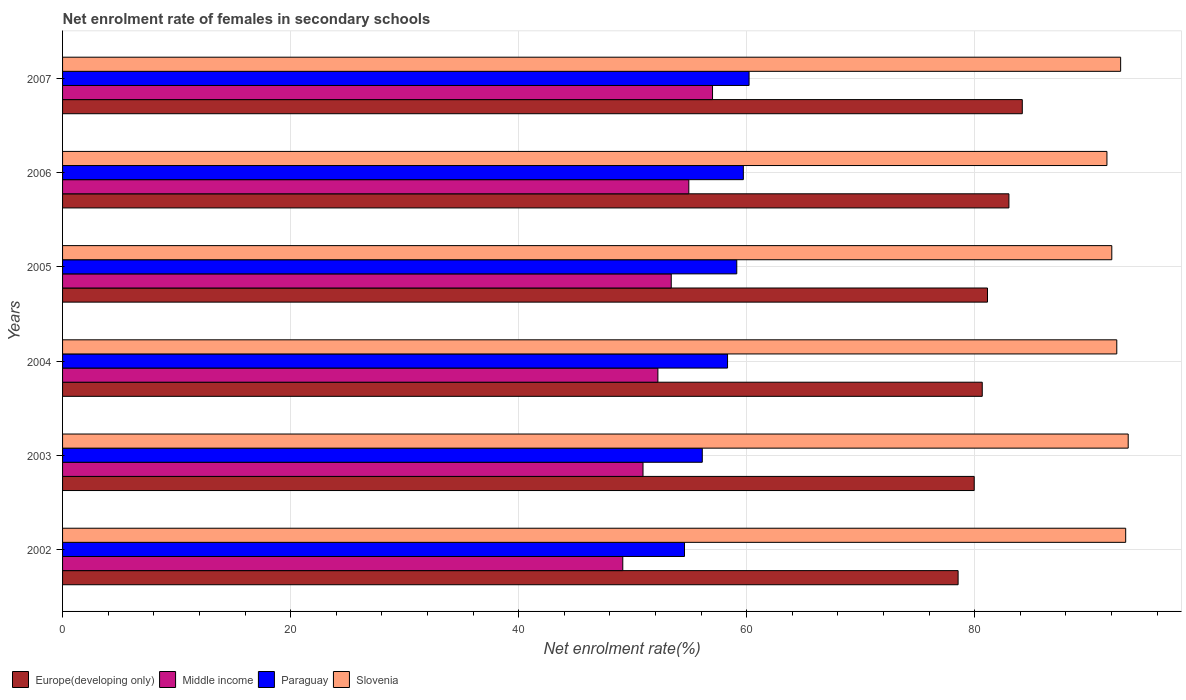How many groups of bars are there?
Provide a short and direct response. 6. Are the number of bars per tick equal to the number of legend labels?
Your response must be concise. Yes. What is the label of the 1st group of bars from the top?
Your answer should be compact. 2007. In how many cases, is the number of bars for a given year not equal to the number of legend labels?
Your answer should be very brief. 0. What is the net enrolment rate of females in secondary schools in Slovenia in 2007?
Your response must be concise. 92.8. Across all years, what is the maximum net enrolment rate of females in secondary schools in Europe(developing only)?
Your answer should be very brief. 84.17. Across all years, what is the minimum net enrolment rate of females in secondary schools in Paraguay?
Provide a succinct answer. 54.55. In which year was the net enrolment rate of females in secondary schools in Paraguay minimum?
Offer a terse response. 2002. What is the total net enrolment rate of females in secondary schools in Slovenia in the graph?
Provide a short and direct response. 555.58. What is the difference between the net enrolment rate of females in secondary schools in Europe(developing only) in 2004 and that in 2007?
Keep it short and to the point. -3.51. What is the difference between the net enrolment rate of females in secondary schools in Paraguay in 2006 and the net enrolment rate of females in secondary schools in Middle income in 2003?
Offer a terse response. 8.8. What is the average net enrolment rate of females in secondary schools in Paraguay per year?
Keep it short and to the point. 58. In the year 2004, what is the difference between the net enrolment rate of females in secondary schools in Slovenia and net enrolment rate of females in secondary schools in Paraguay?
Your response must be concise. 34.14. In how many years, is the net enrolment rate of females in secondary schools in Middle income greater than 36 %?
Provide a succinct answer. 6. What is the ratio of the net enrolment rate of females in secondary schools in Middle income in 2005 to that in 2006?
Ensure brevity in your answer.  0.97. What is the difference between the highest and the second highest net enrolment rate of females in secondary schools in Middle income?
Make the answer very short. 2.08. What is the difference between the highest and the lowest net enrolment rate of females in secondary schools in Middle income?
Your answer should be compact. 7.87. Is the sum of the net enrolment rate of females in secondary schools in Europe(developing only) in 2003 and 2004 greater than the maximum net enrolment rate of females in secondary schools in Slovenia across all years?
Give a very brief answer. Yes. What does the 1st bar from the top in 2004 represents?
Keep it short and to the point. Slovenia. What does the 2nd bar from the bottom in 2007 represents?
Give a very brief answer. Middle income. Is it the case that in every year, the sum of the net enrolment rate of females in secondary schools in Europe(developing only) and net enrolment rate of females in secondary schools in Slovenia is greater than the net enrolment rate of females in secondary schools in Paraguay?
Provide a short and direct response. Yes. How many bars are there?
Provide a short and direct response. 24. Are all the bars in the graph horizontal?
Keep it short and to the point. Yes. What is the difference between two consecutive major ticks on the X-axis?
Provide a succinct answer. 20. Are the values on the major ticks of X-axis written in scientific E-notation?
Your answer should be compact. No. Does the graph contain any zero values?
Provide a short and direct response. No. Does the graph contain grids?
Your answer should be very brief. Yes. How many legend labels are there?
Provide a succinct answer. 4. What is the title of the graph?
Provide a short and direct response. Net enrolment rate of females in secondary schools. What is the label or title of the X-axis?
Offer a very short reply. Net enrolment rate(%). What is the Net enrolment rate(%) of Europe(developing only) in 2002?
Offer a terse response. 78.54. What is the Net enrolment rate(%) in Middle income in 2002?
Give a very brief answer. 49.13. What is the Net enrolment rate(%) in Paraguay in 2002?
Provide a succinct answer. 54.55. What is the Net enrolment rate(%) of Slovenia in 2002?
Your answer should be very brief. 93.24. What is the Net enrolment rate(%) in Europe(developing only) in 2003?
Provide a short and direct response. 79.96. What is the Net enrolment rate(%) of Middle income in 2003?
Make the answer very short. 50.91. What is the Net enrolment rate(%) in Paraguay in 2003?
Your response must be concise. 56.11. What is the Net enrolment rate(%) of Slovenia in 2003?
Keep it short and to the point. 93.46. What is the Net enrolment rate(%) in Europe(developing only) in 2004?
Offer a very short reply. 80.66. What is the Net enrolment rate(%) of Middle income in 2004?
Ensure brevity in your answer.  52.21. What is the Net enrolment rate(%) in Paraguay in 2004?
Provide a succinct answer. 58.32. What is the Net enrolment rate(%) of Slovenia in 2004?
Give a very brief answer. 92.46. What is the Net enrolment rate(%) of Europe(developing only) in 2005?
Your answer should be compact. 81.12. What is the Net enrolment rate(%) in Middle income in 2005?
Offer a terse response. 53.38. What is the Net enrolment rate(%) in Paraguay in 2005?
Make the answer very short. 59.13. What is the Net enrolment rate(%) of Slovenia in 2005?
Make the answer very short. 92.02. What is the Net enrolment rate(%) of Europe(developing only) in 2006?
Make the answer very short. 83. What is the Net enrolment rate(%) of Middle income in 2006?
Offer a terse response. 54.93. What is the Net enrolment rate(%) of Paraguay in 2006?
Provide a succinct answer. 59.71. What is the Net enrolment rate(%) in Slovenia in 2006?
Keep it short and to the point. 91.6. What is the Net enrolment rate(%) in Europe(developing only) in 2007?
Your response must be concise. 84.17. What is the Net enrolment rate(%) of Middle income in 2007?
Your answer should be very brief. 57.01. What is the Net enrolment rate(%) in Paraguay in 2007?
Provide a succinct answer. 60.21. What is the Net enrolment rate(%) of Slovenia in 2007?
Offer a terse response. 92.8. Across all years, what is the maximum Net enrolment rate(%) in Europe(developing only)?
Provide a short and direct response. 84.17. Across all years, what is the maximum Net enrolment rate(%) in Middle income?
Ensure brevity in your answer.  57.01. Across all years, what is the maximum Net enrolment rate(%) in Paraguay?
Give a very brief answer. 60.21. Across all years, what is the maximum Net enrolment rate(%) of Slovenia?
Provide a succinct answer. 93.46. Across all years, what is the minimum Net enrolment rate(%) of Europe(developing only)?
Your answer should be compact. 78.54. Across all years, what is the minimum Net enrolment rate(%) in Middle income?
Your answer should be compact. 49.13. Across all years, what is the minimum Net enrolment rate(%) in Paraguay?
Ensure brevity in your answer.  54.55. Across all years, what is the minimum Net enrolment rate(%) of Slovenia?
Your answer should be compact. 91.6. What is the total Net enrolment rate(%) in Europe(developing only) in the graph?
Offer a very short reply. 487.45. What is the total Net enrolment rate(%) of Middle income in the graph?
Make the answer very short. 317.57. What is the total Net enrolment rate(%) in Paraguay in the graph?
Make the answer very short. 348.02. What is the total Net enrolment rate(%) of Slovenia in the graph?
Keep it short and to the point. 555.58. What is the difference between the Net enrolment rate(%) in Europe(developing only) in 2002 and that in 2003?
Your answer should be compact. -1.41. What is the difference between the Net enrolment rate(%) in Middle income in 2002 and that in 2003?
Ensure brevity in your answer.  -1.77. What is the difference between the Net enrolment rate(%) in Paraguay in 2002 and that in 2003?
Make the answer very short. -1.56. What is the difference between the Net enrolment rate(%) in Slovenia in 2002 and that in 2003?
Your response must be concise. -0.22. What is the difference between the Net enrolment rate(%) of Europe(developing only) in 2002 and that in 2004?
Offer a very short reply. -2.12. What is the difference between the Net enrolment rate(%) in Middle income in 2002 and that in 2004?
Provide a succinct answer. -3.08. What is the difference between the Net enrolment rate(%) of Paraguay in 2002 and that in 2004?
Provide a short and direct response. -3.78. What is the difference between the Net enrolment rate(%) of Slovenia in 2002 and that in 2004?
Give a very brief answer. 0.78. What is the difference between the Net enrolment rate(%) of Europe(developing only) in 2002 and that in 2005?
Offer a terse response. -2.58. What is the difference between the Net enrolment rate(%) of Middle income in 2002 and that in 2005?
Your answer should be very brief. -4.25. What is the difference between the Net enrolment rate(%) in Paraguay in 2002 and that in 2005?
Keep it short and to the point. -4.58. What is the difference between the Net enrolment rate(%) in Slovenia in 2002 and that in 2005?
Your answer should be compact. 1.22. What is the difference between the Net enrolment rate(%) in Europe(developing only) in 2002 and that in 2006?
Make the answer very short. -4.46. What is the difference between the Net enrolment rate(%) of Middle income in 2002 and that in 2006?
Make the answer very short. -5.79. What is the difference between the Net enrolment rate(%) of Paraguay in 2002 and that in 2006?
Give a very brief answer. -5.16. What is the difference between the Net enrolment rate(%) in Slovenia in 2002 and that in 2006?
Ensure brevity in your answer.  1.64. What is the difference between the Net enrolment rate(%) of Europe(developing only) in 2002 and that in 2007?
Ensure brevity in your answer.  -5.63. What is the difference between the Net enrolment rate(%) in Middle income in 2002 and that in 2007?
Offer a very short reply. -7.87. What is the difference between the Net enrolment rate(%) in Paraguay in 2002 and that in 2007?
Offer a very short reply. -5.66. What is the difference between the Net enrolment rate(%) in Slovenia in 2002 and that in 2007?
Keep it short and to the point. 0.44. What is the difference between the Net enrolment rate(%) in Europe(developing only) in 2003 and that in 2004?
Keep it short and to the point. -0.7. What is the difference between the Net enrolment rate(%) of Middle income in 2003 and that in 2004?
Your answer should be very brief. -1.3. What is the difference between the Net enrolment rate(%) in Paraguay in 2003 and that in 2004?
Make the answer very short. -2.22. What is the difference between the Net enrolment rate(%) in Europe(developing only) in 2003 and that in 2005?
Give a very brief answer. -1.16. What is the difference between the Net enrolment rate(%) of Middle income in 2003 and that in 2005?
Give a very brief answer. -2.48. What is the difference between the Net enrolment rate(%) of Paraguay in 2003 and that in 2005?
Your response must be concise. -3.02. What is the difference between the Net enrolment rate(%) of Slovenia in 2003 and that in 2005?
Provide a short and direct response. 1.44. What is the difference between the Net enrolment rate(%) in Europe(developing only) in 2003 and that in 2006?
Offer a terse response. -3.04. What is the difference between the Net enrolment rate(%) in Middle income in 2003 and that in 2006?
Your answer should be very brief. -4.02. What is the difference between the Net enrolment rate(%) of Paraguay in 2003 and that in 2006?
Give a very brief answer. -3.6. What is the difference between the Net enrolment rate(%) in Slovenia in 2003 and that in 2006?
Provide a short and direct response. 1.87. What is the difference between the Net enrolment rate(%) of Europe(developing only) in 2003 and that in 2007?
Your answer should be very brief. -4.22. What is the difference between the Net enrolment rate(%) of Middle income in 2003 and that in 2007?
Your response must be concise. -6.1. What is the difference between the Net enrolment rate(%) of Paraguay in 2003 and that in 2007?
Provide a short and direct response. -4.1. What is the difference between the Net enrolment rate(%) of Slovenia in 2003 and that in 2007?
Your answer should be compact. 0.66. What is the difference between the Net enrolment rate(%) in Europe(developing only) in 2004 and that in 2005?
Give a very brief answer. -0.46. What is the difference between the Net enrolment rate(%) in Middle income in 2004 and that in 2005?
Keep it short and to the point. -1.17. What is the difference between the Net enrolment rate(%) in Paraguay in 2004 and that in 2005?
Your answer should be very brief. -0.81. What is the difference between the Net enrolment rate(%) in Slovenia in 2004 and that in 2005?
Give a very brief answer. 0.44. What is the difference between the Net enrolment rate(%) of Europe(developing only) in 2004 and that in 2006?
Make the answer very short. -2.34. What is the difference between the Net enrolment rate(%) of Middle income in 2004 and that in 2006?
Keep it short and to the point. -2.71. What is the difference between the Net enrolment rate(%) of Paraguay in 2004 and that in 2006?
Your answer should be compact. -1.39. What is the difference between the Net enrolment rate(%) in Slovenia in 2004 and that in 2006?
Offer a terse response. 0.86. What is the difference between the Net enrolment rate(%) of Europe(developing only) in 2004 and that in 2007?
Provide a short and direct response. -3.51. What is the difference between the Net enrolment rate(%) of Middle income in 2004 and that in 2007?
Offer a terse response. -4.79. What is the difference between the Net enrolment rate(%) in Paraguay in 2004 and that in 2007?
Offer a terse response. -1.89. What is the difference between the Net enrolment rate(%) in Slovenia in 2004 and that in 2007?
Keep it short and to the point. -0.34. What is the difference between the Net enrolment rate(%) of Europe(developing only) in 2005 and that in 2006?
Give a very brief answer. -1.88. What is the difference between the Net enrolment rate(%) of Middle income in 2005 and that in 2006?
Provide a short and direct response. -1.54. What is the difference between the Net enrolment rate(%) of Paraguay in 2005 and that in 2006?
Offer a terse response. -0.58. What is the difference between the Net enrolment rate(%) in Slovenia in 2005 and that in 2006?
Give a very brief answer. 0.43. What is the difference between the Net enrolment rate(%) in Europe(developing only) in 2005 and that in 2007?
Offer a very short reply. -3.05. What is the difference between the Net enrolment rate(%) of Middle income in 2005 and that in 2007?
Your response must be concise. -3.62. What is the difference between the Net enrolment rate(%) of Paraguay in 2005 and that in 2007?
Make the answer very short. -1.08. What is the difference between the Net enrolment rate(%) of Slovenia in 2005 and that in 2007?
Offer a terse response. -0.78. What is the difference between the Net enrolment rate(%) of Europe(developing only) in 2006 and that in 2007?
Give a very brief answer. -1.17. What is the difference between the Net enrolment rate(%) in Middle income in 2006 and that in 2007?
Keep it short and to the point. -2.08. What is the difference between the Net enrolment rate(%) of Paraguay in 2006 and that in 2007?
Provide a succinct answer. -0.5. What is the difference between the Net enrolment rate(%) of Slovenia in 2006 and that in 2007?
Give a very brief answer. -1.2. What is the difference between the Net enrolment rate(%) of Europe(developing only) in 2002 and the Net enrolment rate(%) of Middle income in 2003?
Offer a terse response. 27.64. What is the difference between the Net enrolment rate(%) in Europe(developing only) in 2002 and the Net enrolment rate(%) in Paraguay in 2003?
Your answer should be very brief. 22.44. What is the difference between the Net enrolment rate(%) in Europe(developing only) in 2002 and the Net enrolment rate(%) in Slovenia in 2003?
Keep it short and to the point. -14.92. What is the difference between the Net enrolment rate(%) of Middle income in 2002 and the Net enrolment rate(%) of Paraguay in 2003?
Your response must be concise. -6.97. What is the difference between the Net enrolment rate(%) of Middle income in 2002 and the Net enrolment rate(%) of Slovenia in 2003?
Offer a very short reply. -44.33. What is the difference between the Net enrolment rate(%) in Paraguay in 2002 and the Net enrolment rate(%) in Slovenia in 2003?
Provide a short and direct response. -38.92. What is the difference between the Net enrolment rate(%) of Europe(developing only) in 2002 and the Net enrolment rate(%) of Middle income in 2004?
Keep it short and to the point. 26.33. What is the difference between the Net enrolment rate(%) in Europe(developing only) in 2002 and the Net enrolment rate(%) in Paraguay in 2004?
Keep it short and to the point. 20.22. What is the difference between the Net enrolment rate(%) of Europe(developing only) in 2002 and the Net enrolment rate(%) of Slovenia in 2004?
Your answer should be compact. -13.92. What is the difference between the Net enrolment rate(%) of Middle income in 2002 and the Net enrolment rate(%) of Paraguay in 2004?
Give a very brief answer. -9.19. What is the difference between the Net enrolment rate(%) of Middle income in 2002 and the Net enrolment rate(%) of Slovenia in 2004?
Your answer should be compact. -43.33. What is the difference between the Net enrolment rate(%) in Paraguay in 2002 and the Net enrolment rate(%) in Slovenia in 2004?
Offer a very short reply. -37.91. What is the difference between the Net enrolment rate(%) of Europe(developing only) in 2002 and the Net enrolment rate(%) of Middle income in 2005?
Keep it short and to the point. 25.16. What is the difference between the Net enrolment rate(%) in Europe(developing only) in 2002 and the Net enrolment rate(%) in Paraguay in 2005?
Make the answer very short. 19.41. What is the difference between the Net enrolment rate(%) of Europe(developing only) in 2002 and the Net enrolment rate(%) of Slovenia in 2005?
Give a very brief answer. -13.48. What is the difference between the Net enrolment rate(%) in Middle income in 2002 and the Net enrolment rate(%) in Paraguay in 2005?
Your answer should be very brief. -10. What is the difference between the Net enrolment rate(%) in Middle income in 2002 and the Net enrolment rate(%) in Slovenia in 2005?
Your response must be concise. -42.89. What is the difference between the Net enrolment rate(%) of Paraguay in 2002 and the Net enrolment rate(%) of Slovenia in 2005?
Your answer should be compact. -37.48. What is the difference between the Net enrolment rate(%) in Europe(developing only) in 2002 and the Net enrolment rate(%) in Middle income in 2006?
Offer a very short reply. 23.62. What is the difference between the Net enrolment rate(%) in Europe(developing only) in 2002 and the Net enrolment rate(%) in Paraguay in 2006?
Give a very brief answer. 18.84. What is the difference between the Net enrolment rate(%) in Europe(developing only) in 2002 and the Net enrolment rate(%) in Slovenia in 2006?
Ensure brevity in your answer.  -13.05. What is the difference between the Net enrolment rate(%) in Middle income in 2002 and the Net enrolment rate(%) in Paraguay in 2006?
Offer a terse response. -10.57. What is the difference between the Net enrolment rate(%) in Middle income in 2002 and the Net enrolment rate(%) in Slovenia in 2006?
Give a very brief answer. -42.46. What is the difference between the Net enrolment rate(%) in Paraguay in 2002 and the Net enrolment rate(%) in Slovenia in 2006?
Keep it short and to the point. -37.05. What is the difference between the Net enrolment rate(%) in Europe(developing only) in 2002 and the Net enrolment rate(%) in Middle income in 2007?
Provide a short and direct response. 21.54. What is the difference between the Net enrolment rate(%) in Europe(developing only) in 2002 and the Net enrolment rate(%) in Paraguay in 2007?
Provide a succinct answer. 18.33. What is the difference between the Net enrolment rate(%) of Europe(developing only) in 2002 and the Net enrolment rate(%) of Slovenia in 2007?
Give a very brief answer. -14.26. What is the difference between the Net enrolment rate(%) in Middle income in 2002 and the Net enrolment rate(%) in Paraguay in 2007?
Offer a very short reply. -11.08. What is the difference between the Net enrolment rate(%) of Middle income in 2002 and the Net enrolment rate(%) of Slovenia in 2007?
Make the answer very short. -43.67. What is the difference between the Net enrolment rate(%) in Paraguay in 2002 and the Net enrolment rate(%) in Slovenia in 2007?
Provide a succinct answer. -38.25. What is the difference between the Net enrolment rate(%) in Europe(developing only) in 2003 and the Net enrolment rate(%) in Middle income in 2004?
Offer a very short reply. 27.74. What is the difference between the Net enrolment rate(%) in Europe(developing only) in 2003 and the Net enrolment rate(%) in Paraguay in 2004?
Provide a short and direct response. 21.63. What is the difference between the Net enrolment rate(%) in Europe(developing only) in 2003 and the Net enrolment rate(%) in Slovenia in 2004?
Your response must be concise. -12.5. What is the difference between the Net enrolment rate(%) in Middle income in 2003 and the Net enrolment rate(%) in Paraguay in 2004?
Provide a short and direct response. -7.41. What is the difference between the Net enrolment rate(%) of Middle income in 2003 and the Net enrolment rate(%) of Slovenia in 2004?
Provide a succinct answer. -41.55. What is the difference between the Net enrolment rate(%) of Paraguay in 2003 and the Net enrolment rate(%) of Slovenia in 2004?
Ensure brevity in your answer.  -36.35. What is the difference between the Net enrolment rate(%) of Europe(developing only) in 2003 and the Net enrolment rate(%) of Middle income in 2005?
Provide a succinct answer. 26.57. What is the difference between the Net enrolment rate(%) in Europe(developing only) in 2003 and the Net enrolment rate(%) in Paraguay in 2005?
Offer a terse response. 20.83. What is the difference between the Net enrolment rate(%) in Europe(developing only) in 2003 and the Net enrolment rate(%) in Slovenia in 2005?
Your answer should be very brief. -12.07. What is the difference between the Net enrolment rate(%) in Middle income in 2003 and the Net enrolment rate(%) in Paraguay in 2005?
Ensure brevity in your answer.  -8.22. What is the difference between the Net enrolment rate(%) of Middle income in 2003 and the Net enrolment rate(%) of Slovenia in 2005?
Your response must be concise. -41.11. What is the difference between the Net enrolment rate(%) in Paraguay in 2003 and the Net enrolment rate(%) in Slovenia in 2005?
Make the answer very short. -35.92. What is the difference between the Net enrolment rate(%) in Europe(developing only) in 2003 and the Net enrolment rate(%) in Middle income in 2006?
Provide a short and direct response. 25.03. What is the difference between the Net enrolment rate(%) of Europe(developing only) in 2003 and the Net enrolment rate(%) of Paraguay in 2006?
Your response must be concise. 20.25. What is the difference between the Net enrolment rate(%) in Europe(developing only) in 2003 and the Net enrolment rate(%) in Slovenia in 2006?
Your answer should be very brief. -11.64. What is the difference between the Net enrolment rate(%) in Middle income in 2003 and the Net enrolment rate(%) in Paraguay in 2006?
Your response must be concise. -8.8. What is the difference between the Net enrolment rate(%) in Middle income in 2003 and the Net enrolment rate(%) in Slovenia in 2006?
Your response must be concise. -40.69. What is the difference between the Net enrolment rate(%) of Paraguay in 2003 and the Net enrolment rate(%) of Slovenia in 2006?
Offer a very short reply. -35.49. What is the difference between the Net enrolment rate(%) in Europe(developing only) in 2003 and the Net enrolment rate(%) in Middle income in 2007?
Provide a short and direct response. 22.95. What is the difference between the Net enrolment rate(%) of Europe(developing only) in 2003 and the Net enrolment rate(%) of Paraguay in 2007?
Provide a short and direct response. 19.75. What is the difference between the Net enrolment rate(%) of Europe(developing only) in 2003 and the Net enrolment rate(%) of Slovenia in 2007?
Your answer should be very brief. -12.84. What is the difference between the Net enrolment rate(%) of Middle income in 2003 and the Net enrolment rate(%) of Paraguay in 2007?
Give a very brief answer. -9.3. What is the difference between the Net enrolment rate(%) in Middle income in 2003 and the Net enrolment rate(%) in Slovenia in 2007?
Give a very brief answer. -41.89. What is the difference between the Net enrolment rate(%) in Paraguay in 2003 and the Net enrolment rate(%) in Slovenia in 2007?
Keep it short and to the point. -36.69. What is the difference between the Net enrolment rate(%) of Europe(developing only) in 2004 and the Net enrolment rate(%) of Middle income in 2005?
Your answer should be compact. 27.28. What is the difference between the Net enrolment rate(%) of Europe(developing only) in 2004 and the Net enrolment rate(%) of Paraguay in 2005?
Your answer should be compact. 21.53. What is the difference between the Net enrolment rate(%) in Europe(developing only) in 2004 and the Net enrolment rate(%) in Slovenia in 2005?
Your answer should be very brief. -11.36. What is the difference between the Net enrolment rate(%) of Middle income in 2004 and the Net enrolment rate(%) of Paraguay in 2005?
Provide a succinct answer. -6.92. What is the difference between the Net enrolment rate(%) in Middle income in 2004 and the Net enrolment rate(%) in Slovenia in 2005?
Your response must be concise. -39.81. What is the difference between the Net enrolment rate(%) in Paraguay in 2004 and the Net enrolment rate(%) in Slovenia in 2005?
Give a very brief answer. -33.7. What is the difference between the Net enrolment rate(%) of Europe(developing only) in 2004 and the Net enrolment rate(%) of Middle income in 2006?
Your answer should be compact. 25.73. What is the difference between the Net enrolment rate(%) of Europe(developing only) in 2004 and the Net enrolment rate(%) of Paraguay in 2006?
Provide a short and direct response. 20.95. What is the difference between the Net enrolment rate(%) in Europe(developing only) in 2004 and the Net enrolment rate(%) in Slovenia in 2006?
Provide a short and direct response. -10.94. What is the difference between the Net enrolment rate(%) in Middle income in 2004 and the Net enrolment rate(%) in Paraguay in 2006?
Give a very brief answer. -7.49. What is the difference between the Net enrolment rate(%) in Middle income in 2004 and the Net enrolment rate(%) in Slovenia in 2006?
Your response must be concise. -39.38. What is the difference between the Net enrolment rate(%) in Paraguay in 2004 and the Net enrolment rate(%) in Slovenia in 2006?
Keep it short and to the point. -33.27. What is the difference between the Net enrolment rate(%) in Europe(developing only) in 2004 and the Net enrolment rate(%) in Middle income in 2007?
Ensure brevity in your answer.  23.65. What is the difference between the Net enrolment rate(%) of Europe(developing only) in 2004 and the Net enrolment rate(%) of Paraguay in 2007?
Ensure brevity in your answer.  20.45. What is the difference between the Net enrolment rate(%) of Europe(developing only) in 2004 and the Net enrolment rate(%) of Slovenia in 2007?
Offer a terse response. -12.14. What is the difference between the Net enrolment rate(%) of Middle income in 2004 and the Net enrolment rate(%) of Paraguay in 2007?
Your answer should be very brief. -8. What is the difference between the Net enrolment rate(%) in Middle income in 2004 and the Net enrolment rate(%) in Slovenia in 2007?
Give a very brief answer. -40.59. What is the difference between the Net enrolment rate(%) in Paraguay in 2004 and the Net enrolment rate(%) in Slovenia in 2007?
Make the answer very short. -34.48. What is the difference between the Net enrolment rate(%) of Europe(developing only) in 2005 and the Net enrolment rate(%) of Middle income in 2006?
Offer a very short reply. 26.2. What is the difference between the Net enrolment rate(%) of Europe(developing only) in 2005 and the Net enrolment rate(%) of Paraguay in 2006?
Your answer should be very brief. 21.41. What is the difference between the Net enrolment rate(%) of Europe(developing only) in 2005 and the Net enrolment rate(%) of Slovenia in 2006?
Your answer should be compact. -10.48. What is the difference between the Net enrolment rate(%) of Middle income in 2005 and the Net enrolment rate(%) of Paraguay in 2006?
Provide a short and direct response. -6.32. What is the difference between the Net enrolment rate(%) in Middle income in 2005 and the Net enrolment rate(%) in Slovenia in 2006?
Your answer should be compact. -38.21. What is the difference between the Net enrolment rate(%) of Paraguay in 2005 and the Net enrolment rate(%) of Slovenia in 2006?
Your answer should be compact. -32.47. What is the difference between the Net enrolment rate(%) of Europe(developing only) in 2005 and the Net enrolment rate(%) of Middle income in 2007?
Ensure brevity in your answer.  24.12. What is the difference between the Net enrolment rate(%) in Europe(developing only) in 2005 and the Net enrolment rate(%) in Paraguay in 2007?
Ensure brevity in your answer.  20.91. What is the difference between the Net enrolment rate(%) of Europe(developing only) in 2005 and the Net enrolment rate(%) of Slovenia in 2007?
Offer a terse response. -11.68. What is the difference between the Net enrolment rate(%) in Middle income in 2005 and the Net enrolment rate(%) in Paraguay in 2007?
Keep it short and to the point. -6.83. What is the difference between the Net enrolment rate(%) in Middle income in 2005 and the Net enrolment rate(%) in Slovenia in 2007?
Your answer should be compact. -39.41. What is the difference between the Net enrolment rate(%) of Paraguay in 2005 and the Net enrolment rate(%) of Slovenia in 2007?
Provide a short and direct response. -33.67. What is the difference between the Net enrolment rate(%) of Europe(developing only) in 2006 and the Net enrolment rate(%) of Middle income in 2007?
Offer a very short reply. 25.99. What is the difference between the Net enrolment rate(%) in Europe(developing only) in 2006 and the Net enrolment rate(%) in Paraguay in 2007?
Keep it short and to the point. 22.79. What is the difference between the Net enrolment rate(%) of Europe(developing only) in 2006 and the Net enrolment rate(%) of Slovenia in 2007?
Provide a succinct answer. -9.8. What is the difference between the Net enrolment rate(%) of Middle income in 2006 and the Net enrolment rate(%) of Paraguay in 2007?
Offer a very short reply. -5.29. What is the difference between the Net enrolment rate(%) of Middle income in 2006 and the Net enrolment rate(%) of Slovenia in 2007?
Give a very brief answer. -37.87. What is the difference between the Net enrolment rate(%) of Paraguay in 2006 and the Net enrolment rate(%) of Slovenia in 2007?
Offer a terse response. -33.09. What is the average Net enrolment rate(%) in Europe(developing only) per year?
Your answer should be compact. 81.24. What is the average Net enrolment rate(%) in Middle income per year?
Your answer should be very brief. 52.93. What is the average Net enrolment rate(%) in Paraguay per year?
Provide a succinct answer. 58. What is the average Net enrolment rate(%) of Slovenia per year?
Your answer should be very brief. 92.6. In the year 2002, what is the difference between the Net enrolment rate(%) of Europe(developing only) and Net enrolment rate(%) of Middle income?
Offer a terse response. 29.41. In the year 2002, what is the difference between the Net enrolment rate(%) in Europe(developing only) and Net enrolment rate(%) in Paraguay?
Your response must be concise. 24. In the year 2002, what is the difference between the Net enrolment rate(%) of Europe(developing only) and Net enrolment rate(%) of Slovenia?
Offer a very short reply. -14.7. In the year 2002, what is the difference between the Net enrolment rate(%) of Middle income and Net enrolment rate(%) of Paraguay?
Keep it short and to the point. -5.41. In the year 2002, what is the difference between the Net enrolment rate(%) of Middle income and Net enrolment rate(%) of Slovenia?
Provide a short and direct response. -44.11. In the year 2002, what is the difference between the Net enrolment rate(%) of Paraguay and Net enrolment rate(%) of Slovenia?
Give a very brief answer. -38.69. In the year 2003, what is the difference between the Net enrolment rate(%) in Europe(developing only) and Net enrolment rate(%) in Middle income?
Ensure brevity in your answer.  29.05. In the year 2003, what is the difference between the Net enrolment rate(%) in Europe(developing only) and Net enrolment rate(%) in Paraguay?
Your response must be concise. 23.85. In the year 2003, what is the difference between the Net enrolment rate(%) in Europe(developing only) and Net enrolment rate(%) in Slovenia?
Make the answer very short. -13.51. In the year 2003, what is the difference between the Net enrolment rate(%) of Middle income and Net enrolment rate(%) of Paraguay?
Make the answer very short. -5.2. In the year 2003, what is the difference between the Net enrolment rate(%) of Middle income and Net enrolment rate(%) of Slovenia?
Provide a succinct answer. -42.55. In the year 2003, what is the difference between the Net enrolment rate(%) in Paraguay and Net enrolment rate(%) in Slovenia?
Give a very brief answer. -37.36. In the year 2004, what is the difference between the Net enrolment rate(%) of Europe(developing only) and Net enrolment rate(%) of Middle income?
Keep it short and to the point. 28.45. In the year 2004, what is the difference between the Net enrolment rate(%) of Europe(developing only) and Net enrolment rate(%) of Paraguay?
Offer a terse response. 22.34. In the year 2004, what is the difference between the Net enrolment rate(%) of Middle income and Net enrolment rate(%) of Paraguay?
Keep it short and to the point. -6.11. In the year 2004, what is the difference between the Net enrolment rate(%) of Middle income and Net enrolment rate(%) of Slovenia?
Your answer should be compact. -40.25. In the year 2004, what is the difference between the Net enrolment rate(%) of Paraguay and Net enrolment rate(%) of Slovenia?
Your answer should be compact. -34.14. In the year 2005, what is the difference between the Net enrolment rate(%) of Europe(developing only) and Net enrolment rate(%) of Middle income?
Keep it short and to the point. 27.74. In the year 2005, what is the difference between the Net enrolment rate(%) of Europe(developing only) and Net enrolment rate(%) of Paraguay?
Offer a very short reply. 21.99. In the year 2005, what is the difference between the Net enrolment rate(%) of Europe(developing only) and Net enrolment rate(%) of Slovenia?
Give a very brief answer. -10.9. In the year 2005, what is the difference between the Net enrolment rate(%) of Middle income and Net enrolment rate(%) of Paraguay?
Your answer should be compact. -5.75. In the year 2005, what is the difference between the Net enrolment rate(%) of Middle income and Net enrolment rate(%) of Slovenia?
Your response must be concise. -38.64. In the year 2005, what is the difference between the Net enrolment rate(%) of Paraguay and Net enrolment rate(%) of Slovenia?
Your answer should be very brief. -32.89. In the year 2006, what is the difference between the Net enrolment rate(%) in Europe(developing only) and Net enrolment rate(%) in Middle income?
Your response must be concise. 28.07. In the year 2006, what is the difference between the Net enrolment rate(%) of Europe(developing only) and Net enrolment rate(%) of Paraguay?
Keep it short and to the point. 23.29. In the year 2006, what is the difference between the Net enrolment rate(%) in Europe(developing only) and Net enrolment rate(%) in Slovenia?
Ensure brevity in your answer.  -8.6. In the year 2006, what is the difference between the Net enrolment rate(%) in Middle income and Net enrolment rate(%) in Paraguay?
Offer a very short reply. -4.78. In the year 2006, what is the difference between the Net enrolment rate(%) of Middle income and Net enrolment rate(%) of Slovenia?
Provide a succinct answer. -36.67. In the year 2006, what is the difference between the Net enrolment rate(%) in Paraguay and Net enrolment rate(%) in Slovenia?
Your response must be concise. -31.89. In the year 2007, what is the difference between the Net enrolment rate(%) of Europe(developing only) and Net enrolment rate(%) of Middle income?
Provide a short and direct response. 27.17. In the year 2007, what is the difference between the Net enrolment rate(%) in Europe(developing only) and Net enrolment rate(%) in Paraguay?
Keep it short and to the point. 23.96. In the year 2007, what is the difference between the Net enrolment rate(%) of Europe(developing only) and Net enrolment rate(%) of Slovenia?
Give a very brief answer. -8.63. In the year 2007, what is the difference between the Net enrolment rate(%) in Middle income and Net enrolment rate(%) in Paraguay?
Ensure brevity in your answer.  -3.21. In the year 2007, what is the difference between the Net enrolment rate(%) of Middle income and Net enrolment rate(%) of Slovenia?
Provide a short and direct response. -35.79. In the year 2007, what is the difference between the Net enrolment rate(%) of Paraguay and Net enrolment rate(%) of Slovenia?
Your response must be concise. -32.59. What is the ratio of the Net enrolment rate(%) in Europe(developing only) in 2002 to that in 2003?
Make the answer very short. 0.98. What is the ratio of the Net enrolment rate(%) of Middle income in 2002 to that in 2003?
Your answer should be compact. 0.97. What is the ratio of the Net enrolment rate(%) in Paraguay in 2002 to that in 2003?
Give a very brief answer. 0.97. What is the ratio of the Net enrolment rate(%) of Europe(developing only) in 2002 to that in 2004?
Provide a succinct answer. 0.97. What is the ratio of the Net enrolment rate(%) of Middle income in 2002 to that in 2004?
Your answer should be very brief. 0.94. What is the ratio of the Net enrolment rate(%) of Paraguay in 2002 to that in 2004?
Your answer should be very brief. 0.94. What is the ratio of the Net enrolment rate(%) of Slovenia in 2002 to that in 2004?
Make the answer very short. 1.01. What is the ratio of the Net enrolment rate(%) in Europe(developing only) in 2002 to that in 2005?
Offer a terse response. 0.97. What is the ratio of the Net enrolment rate(%) of Middle income in 2002 to that in 2005?
Your answer should be compact. 0.92. What is the ratio of the Net enrolment rate(%) of Paraguay in 2002 to that in 2005?
Your response must be concise. 0.92. What is the ratio of the Net enrolment rate(%) of Slovenia in 2002 to that in 2005?
Offer a terse response. 1.01. What is the ratio of the Net enrolment rate(%) of Europe(developing only) in 2002 to that in 2006?
Give a very brief answer. 0.95. What is the ratio of the Net enrolment rate(%) in Middle income in 2002 to that in 2006?
Give a very brief answer. 0.89. What is the ratio of the Net enrolment rate(%) in Paraguay in 2002 to that in 2006?
Your answer should be compact. 0.91. What is the ratio of the Net enrolment rate(%) in Slovenia in 2002 to that in 2006?
Offer a terse response. 1.02. What is the ratio of the Net enrolment rate(%) in Europe(developing only) in 2002 to that in 2007?
Offer a terse response. 0.93. What is the ratio of the Net enrolment rate(%) of Middle income in 2002 to that in 2007?
Keep it short and to the point. 0.86. What is the ratio of the Net enrolment rate(%) of Paraguay in 2002 to that in 2007?
Offer a terse response. 0.91. What is the ratio of the Net enrolment rate(%) in Middle income in 2003 to that in 2004?
Offer a terse response. 0.97. What is the ratio of the Net enrolment rate(%) in Paraguay in 2003 to that in 2004?
Your response must be concise. 0.96. What is the ratio of the Net enrolment rate(%) in Slovenia in 2003 to that in 2004?
Your answer should be very brief. 1.01. What is the ratio of the Net enrolment rate(%) of Europe(developing only) in 2003 to that in 2005?
Your answer should be compact. 0.99. What is the ratio of the Net enrolment rate(%) of Middle income in 2003 to that in 2005?
Give a very brief answer. 0.95. What is the ratio of the Net enrolment rate(%) of Paraguay in 2003 to that in 2005?
Provide a succinct answer. 0.95. What is the ratio of the Net enrolment rate(%) of Slovenia in 2003 to that in 2005?
Ensure brevity in your answer.  1.02. What is the ratio of the Net enrolment rate(%) of Europe(developing only) in 2003 to that in 2006?
Provide a succinct answer. 0.96. What is the ratio of the Net enrolment rate(%) of Middle income in 2003 to that in 2006?
Provide a short and direct response. 0.93. What is the ratio of the Net enrolment rate(%) of Paraguay in 2003 to that in 2006?
Provide a short and direct response. 0.94. What is the ratio of the Net enrolment rate(%) in Slovenia in 2003 to that in 2006?
Provide a short and direct response. 1.02. What is the ratio of the Net enrolment rate(%) of Europe(developing only) in 2003 to that in 2007?
Give a very brief answer. 0.95. What is the ratio of the Net enrolment rate(%) in Middle income in 2003 to that in 2007?
Ensure brevity in your answer.  0.89. What is the ratio of the Net enrolment rate(%) of Paraguay in 2003 to that in 2007?
Your response must be concise. 0.93. What is the ratio of the Net enrolment rate(%) of Middle income in 2004 to that in 2005?
Give a very brief answer. 0.98. What is the ratio of the Net enrolment rate(%) of Paraguay in 2004 to that in 2005?
Your response must be concise. 0.99. What is the ratio of the Net enrolment rate(%) in Europe(developing only) in 2004 to that in 2006?
Ensure brevity in your answer.  0.97. What is the ratio of the Net enrolment rate(%) of Middle income in 2004 to that in 2006?
Make the answer very short. 0.95. What is the ratio of the Net enrolment rate(%) in Paraguay in 2004 to that in 2006?
Ensure brevity in your answer.  0.98. What is the ratio of the Net enrolment rate(%) in Slovenia in 2004 to that in 2006?
Make the answer very short. 1.01. What is the ratio of the Net enrolment rate(%) of Middle income in 2004 to that in 2007?
Give a very brief answer. 0.92. What is the ratio of the Net enrolment rate(%) in Paraguay in 2004 to that in 2007?
Your answer should be compact. 0.97. What is the ratio of the Net enrolment rate(%) in Europe(developing only) in 2005 to that in 2006?
Your answer should be very brief. 0.98. What is the ratio of the Net enrolment rate(%) in Middle income in 2005 to that in 2006?
Offer a terse response. 0.97. What is the ratio of the Net enrolment rate(%) of Paraguay in 2005 to that in 2006?
Provide a short and direct response. 0.99. What is the ratio of the Net enrolment rate(%) of Slovenia in 2005 to that in 2006?
Provide a short and direct response. 1. What is the ratio of the Net enrolment rate(%) in Europe(developing only) in 2005 to that in 2007?
Your response must be concise. 0.96. What is the ratio of the Net enrolment rate(%) in Middle income in 2005 to that in 2007?
Provide a succinct answer. 0.94. What is the ratio of the Net enrolment rate(%) in Paraguay in 2005 to that in 2007?
Offer a very short reply. 0.98. What is the ratio of the Net enrolment rate(%) in Slovenia in 2005 to that in 2007?
Give a very brief answer. 0.99. What is the ratio of the Net enrolment rate(%) of Europe(developing only) in 2006 to that in 2007?
Your answer should be compact. 0.99. What is the ratio of the Net enrolment rate(%) in Middle income in 2006 to that in 2007?
Your answer should be compact. 0.96. What is the difference between the highest and the second highest Net enrolment rate(%) in Europe(developing only)?
Offer a very short reply. 1.17. What is the difference between the highest and the second highest Net enrolment rate(%) of Middle income?
Ensure brevity in your answer.  2.08. What is the difference between the highest and the second highest Net enrolment rate(%) of Paraguay?
Offer a terse response. 0.5. What is the difference between the highest and the second highest Net enrolment rate(%) of Slovenia?
Ensure brevity in your answer.  0.22. What is the difference between the highest and the lowest Net enrolment rate(%) of Europe(developing only)?
Your response must be concise. 5.63. What is the difference between the highest and the lowest Net enrolment rate(%) of Middle income?
Your response must be concise. 7.87. What is the difference between the highest and the lowest Net enrolment rate(%) in Paraguay?
Provide a short and direct response. 5.66. What is the difference between the highest and the lowest Net enrolment rate(%) in Slovenia?
Offer a very short reply. 1.87. 